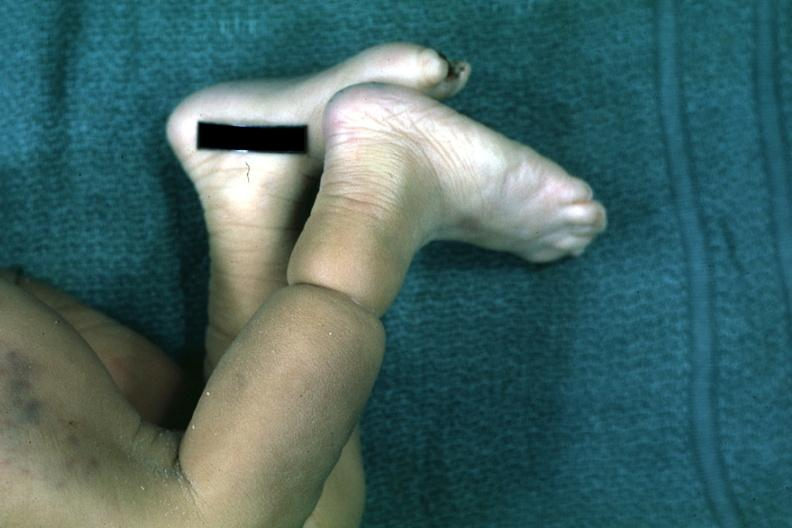s artery looks like an amniotic band lesion?
Answer the question using a single word or phrase. No 